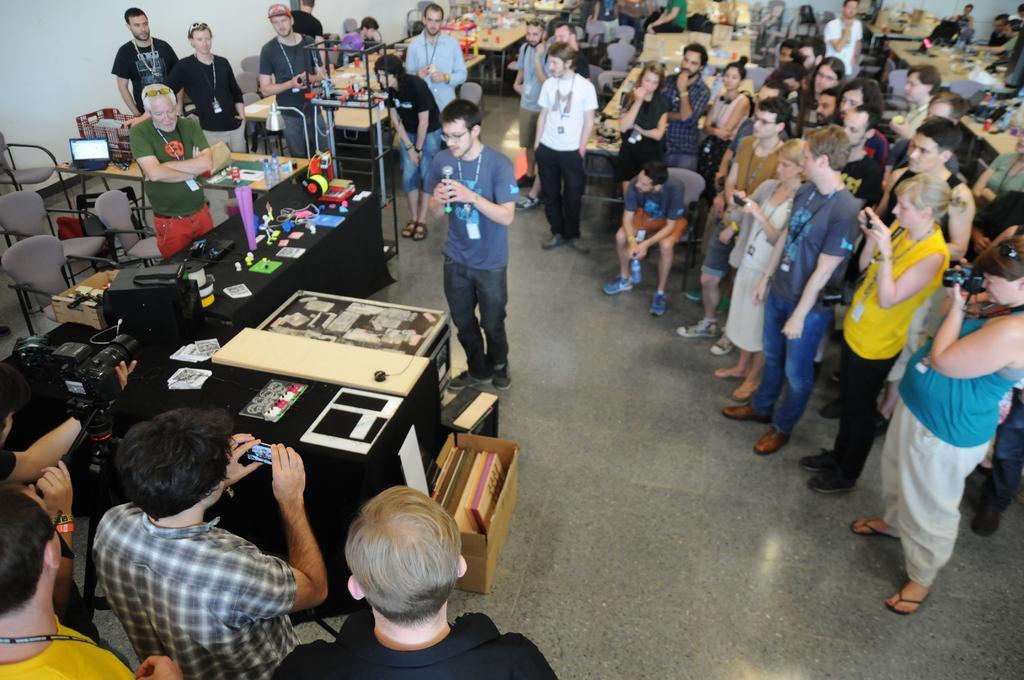Could you give a brief overview of what you see in this image? As we can see in the image there is a white color wall, few people standing here and there and there are chairs and tables. 